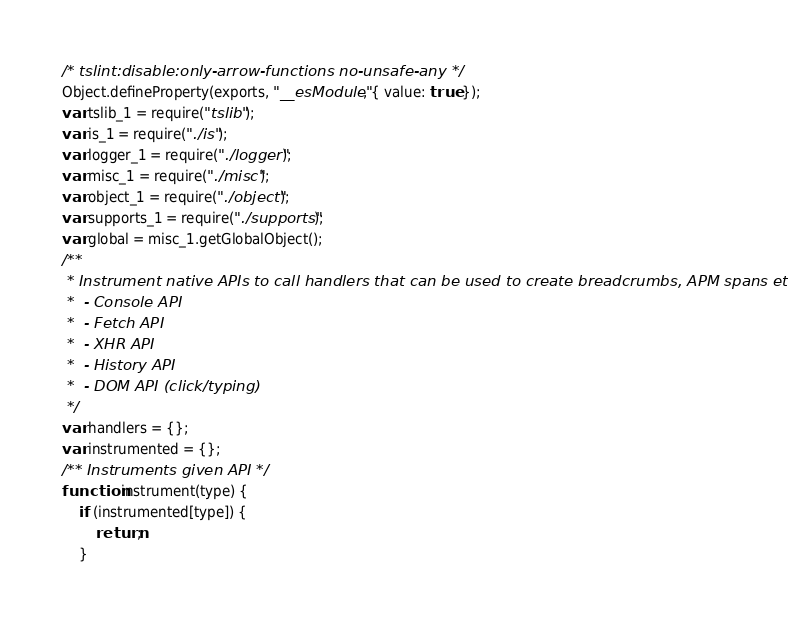<code> <loc_0><loc_0><loc_500><loc_500><_JavaScript_>/* tslint:disable:only-arrow-functions no-unsafe-any */
Object.defineProperty(exports, "__esModule", { value: true });
var tslib_1 = require("tslib");
var is_1 = require("./is");
var logger_1 = require("./logger");
var misc_1 = require("./misc");
var object_1 = require("./object");
var supports_1 = require("./supports");
var global = misc_1.getGlobalObject();
/**
 * Instrument native APIs to call handlers that can be used to create breadcrumbs, APM spans etc.
 *  - Console API
 *  - Fetch API
 *  - XHR API
 *  - History API
 *  - DOM API (click/typing)
 */
var handlers = {};
var instrumented = {};
/** Instruments given API */
function instrument(type) {
    if (instrumented[type]) {
        return;
    }</code> 